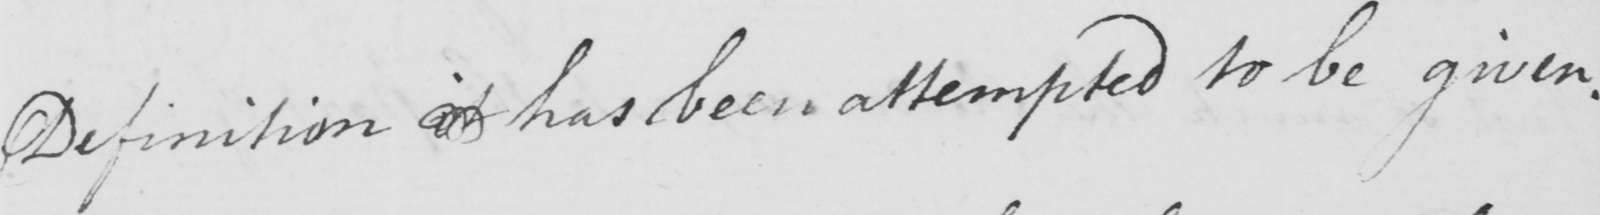Please transcribe the handwritten text in this image. Definition it has been attempted to be given . 